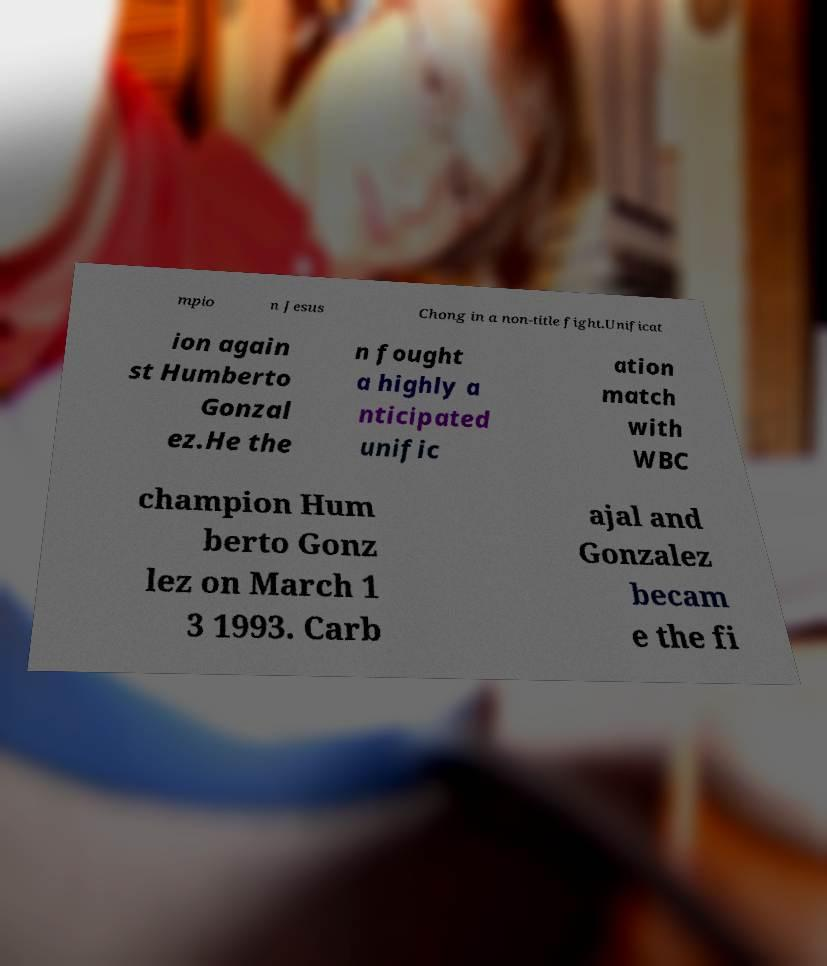I need the written content from this picture converted into text. Can you do that? mpio n Jesus Chong in a non-title fight.Unificat ion again st Humberto Gonzal ez.He the n fought a highly a nticipated unific ation match with WBC champion Hum berto Gonz lez on March 1 3 1993. Carb ajal and Gonzalez becam e the fi 